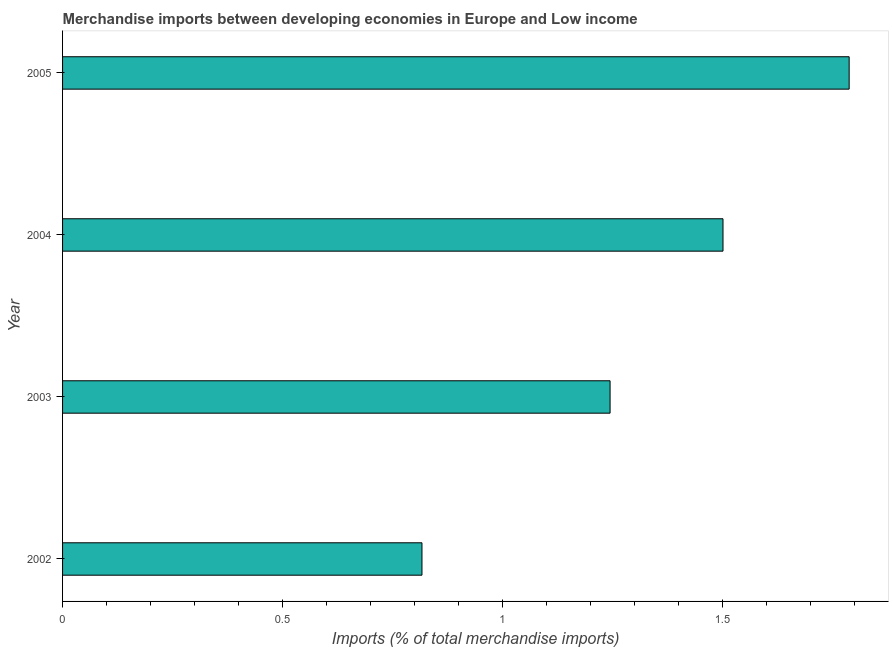Does the graph contain any zero values?
Keep it short and to the point. No. What is the title of the graph?
Your answer should be very brief. Merchandise imports between developing economies in Europe and Low income. What is the label or title of the X-axis?
Offer a terse response. Imports (% of total merchandise imports). What is the merchandise imports in 2003?
Offer a very short reply. 1.24. Across all years, what is the maximum merchandise imports?
Ensure brevity in your answer.  1.79. Across all years, what is the minimum merchandise imports?
Make the answer very short. 0.82. In which year was the merchandise imports minimum?
Provide a short and direct response. 2002. What is the sum of the merchandise imports?
Make the answer very short. 5.35. What is the difference between the merchandise imports in 2004 and 2005?
Provide a succinct answer. -0.29. What is the average merchandise imports per year?
Provide a short and direct response. 1.34. What is the median merchandise imports?
Offer a very short reply. 1.37. In how many years, is the merchandise imports greater than 1.4 %?
Give a very brief answer. 2. What is the ratio of the merchandise imports in 2002 to that in 2005?
Provide a succinct answer. 0.46. Is the merchandise imports in 2003 less than that in 2004?
Your answer should be compact. Yes. Is the difference between the merchandise imports in 2002 and 2005 greater than the difference between any two years?
Make the answer very short. Yes. What is the difference between the highest and the second highest merchandise imports?
Your answer should be compact. 0.29. How many bars are there?
Your answer should be very brief. 4. What is the difference between two consecutive major ticks on the X-axis?
Provide a succinct answer. 0.5. Are the values on the major ticks of X-axis written in scientific E-notation?
Keep it short and to the point. No. What is the Imports (% of total merchandise imports) of 2002?
Your answer should be very brief. 0.82. What is the Imports (% of total merchandise imports) in 2003?
Offer a very short reply. 1.24. What is the Imports (% of total merchandise imports) in 2004?
Ensure brevity in your answer.  1.5. What is the Imports (% of total merchandise imports) in 2005?
Ensure brevity in your answer.  1.79. What is the difference between the Imports (% of total merchandise imports) in 2002 and 2003?
Provide a short and direct response. -0.43. What is the difference between the Imports (% of total merchandise imports) in 2002 and 2004?
Your answer should be compact. -0.68. What is the difference between the Imports (% of total merchandise imports) in 2002 and 2005?
Provide a succinct answer. -0.97. What is the difference between the Imports (% of total merchandise imports) in 2003 and 2004?
Provide a succinct answer. -0.26. What is the difference between the Imports (% of total merchandise imports) in 2003 and 2005?
Ensure brevity in your answer.  -0.54. What is the difference between the Imports (% of total merchandise imports) in 2004 and 2005?
Your response must be concise. -0.29. What is the ratio of the Imports (% of total merchandise imports) in 2002 to that in 2003?
Offer a very short reply. 0.66. What is the ratio of the Imports (% of total merchandise imports) in 2002 to that in 2004?
Provide a succinct answer. 0.54. What is the ratio of the Imports (% of total merchandise imports) in 2002 to that in 2005?
Make the answer very short. 0.46. What is the ratio of the Imports (% of total merchandise imports) in 2003 to that in 2004?
Keep it short and to the point. 0.83. What is the ratio of the Imports (% of total merchandise imports) in 2003 to that in 2005?
Your response must be concise. 0.7. What is the ratio of the Imports (% of total merchandise imports) in 2004 to that in 2005?
Your response must be concise. 0.84. 